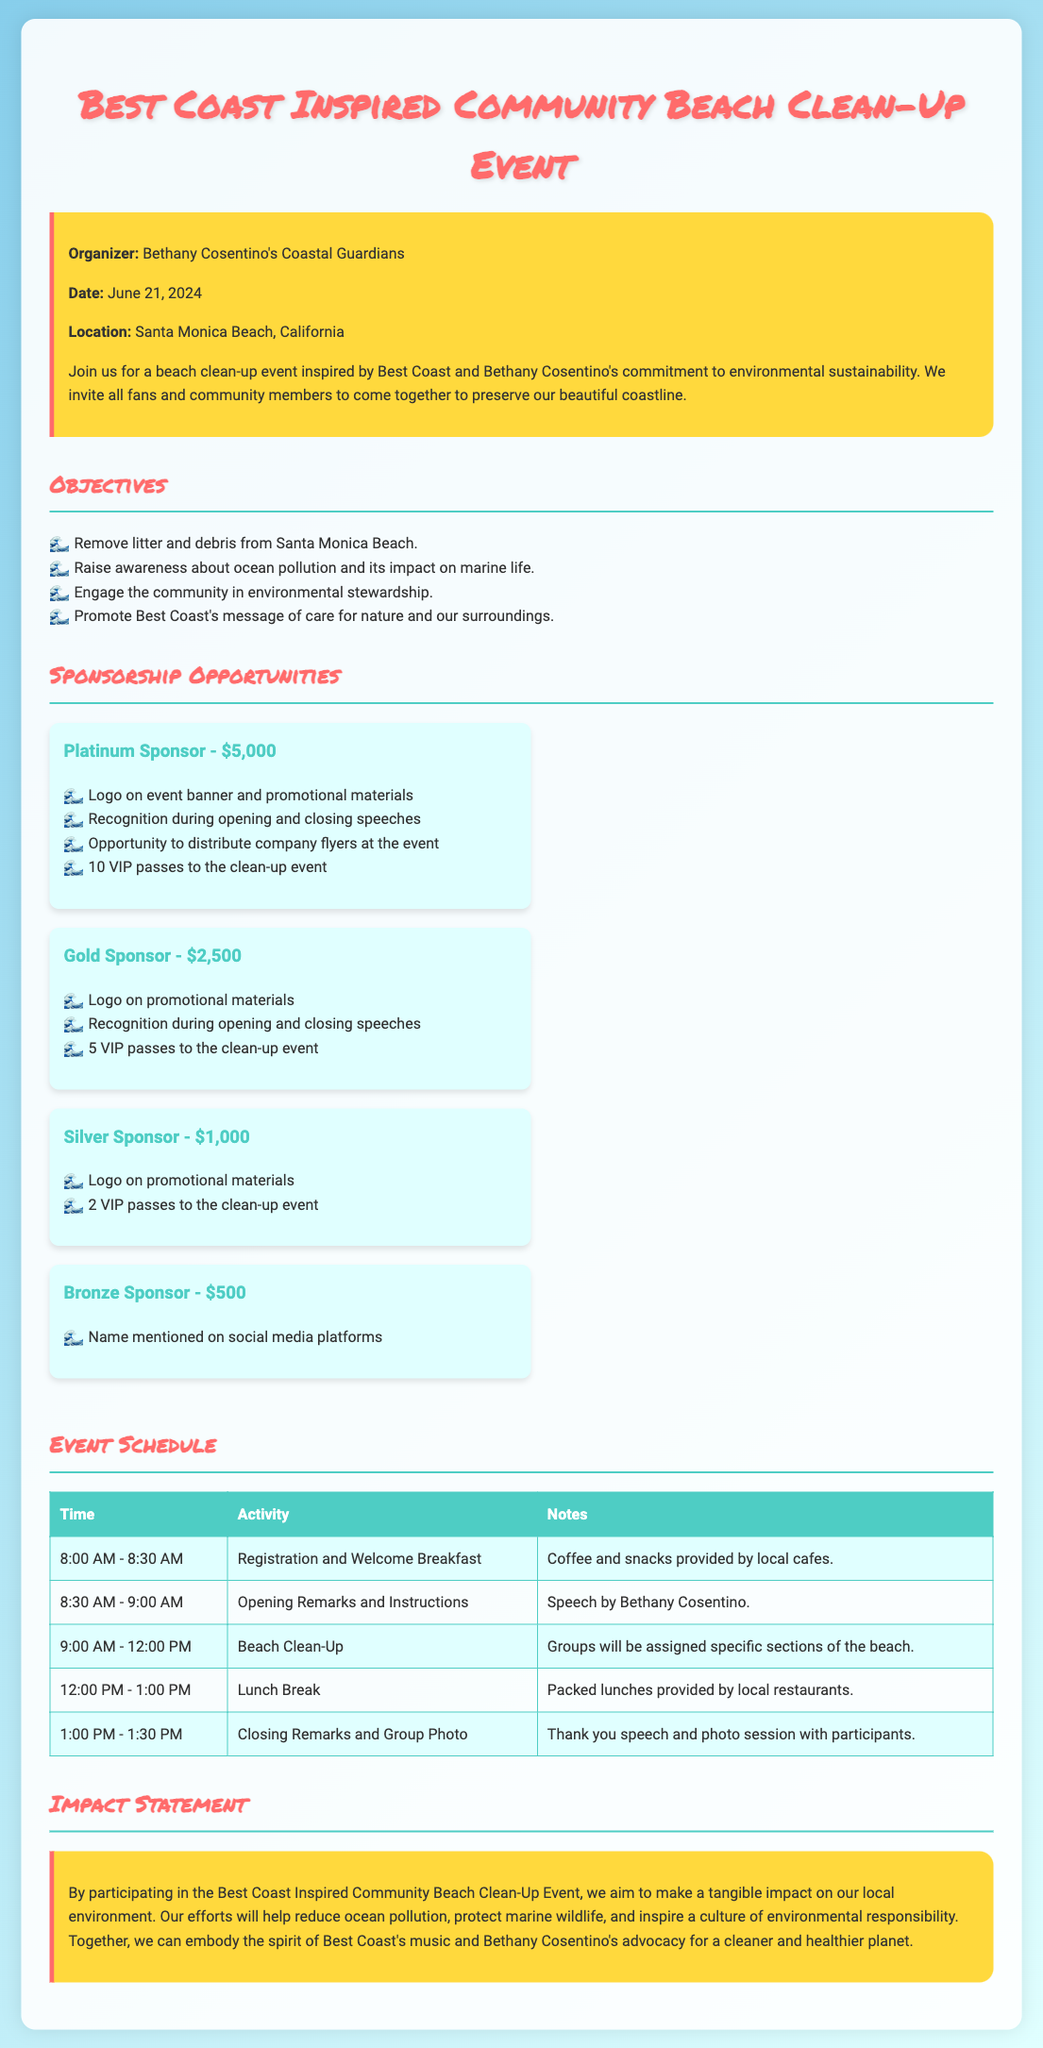What is the date of the event? The date of the event is mentioned in the introduction section of the document.
Answer: June 21, 2024 Who is the organizer of the event? The organizer is stated at the beginning of the document.
Answer: Bethany Cosentino's Coastal Guardians What is the primary location of the clean-up? The location is specified in the introduction section.
Answer: Santa Monica Beach, California How many VIP passes does a Gold Sponsor receive? This detail is listed under the Gold Sponsor section of the sponsorship opportunities.
Answer: 5 VIP passes What are the scheduled activities that start at 9:00 AM? This refers to a specific time in the event schedule.
Answer: Beach Clean-Up What is the total amount for a Platinum Sponsor? This detail is highlighted in the sponsorship opportunities section of the document.
Answer: $5,000 Which activity includes a speech by Bethany Cosentino? The activity is denoted in the event schedule, noting who will be giving the speech.
Answer: Opening Remarks and Instructions What is the impact statement's goal? The impact statement summarizes the intended effect of the event on the environment.
Answer: Reduce ocean pollution What type of event is proposed? The document specifies the type of event right at the beginning.
Answer: Beach Clean-Up Event 